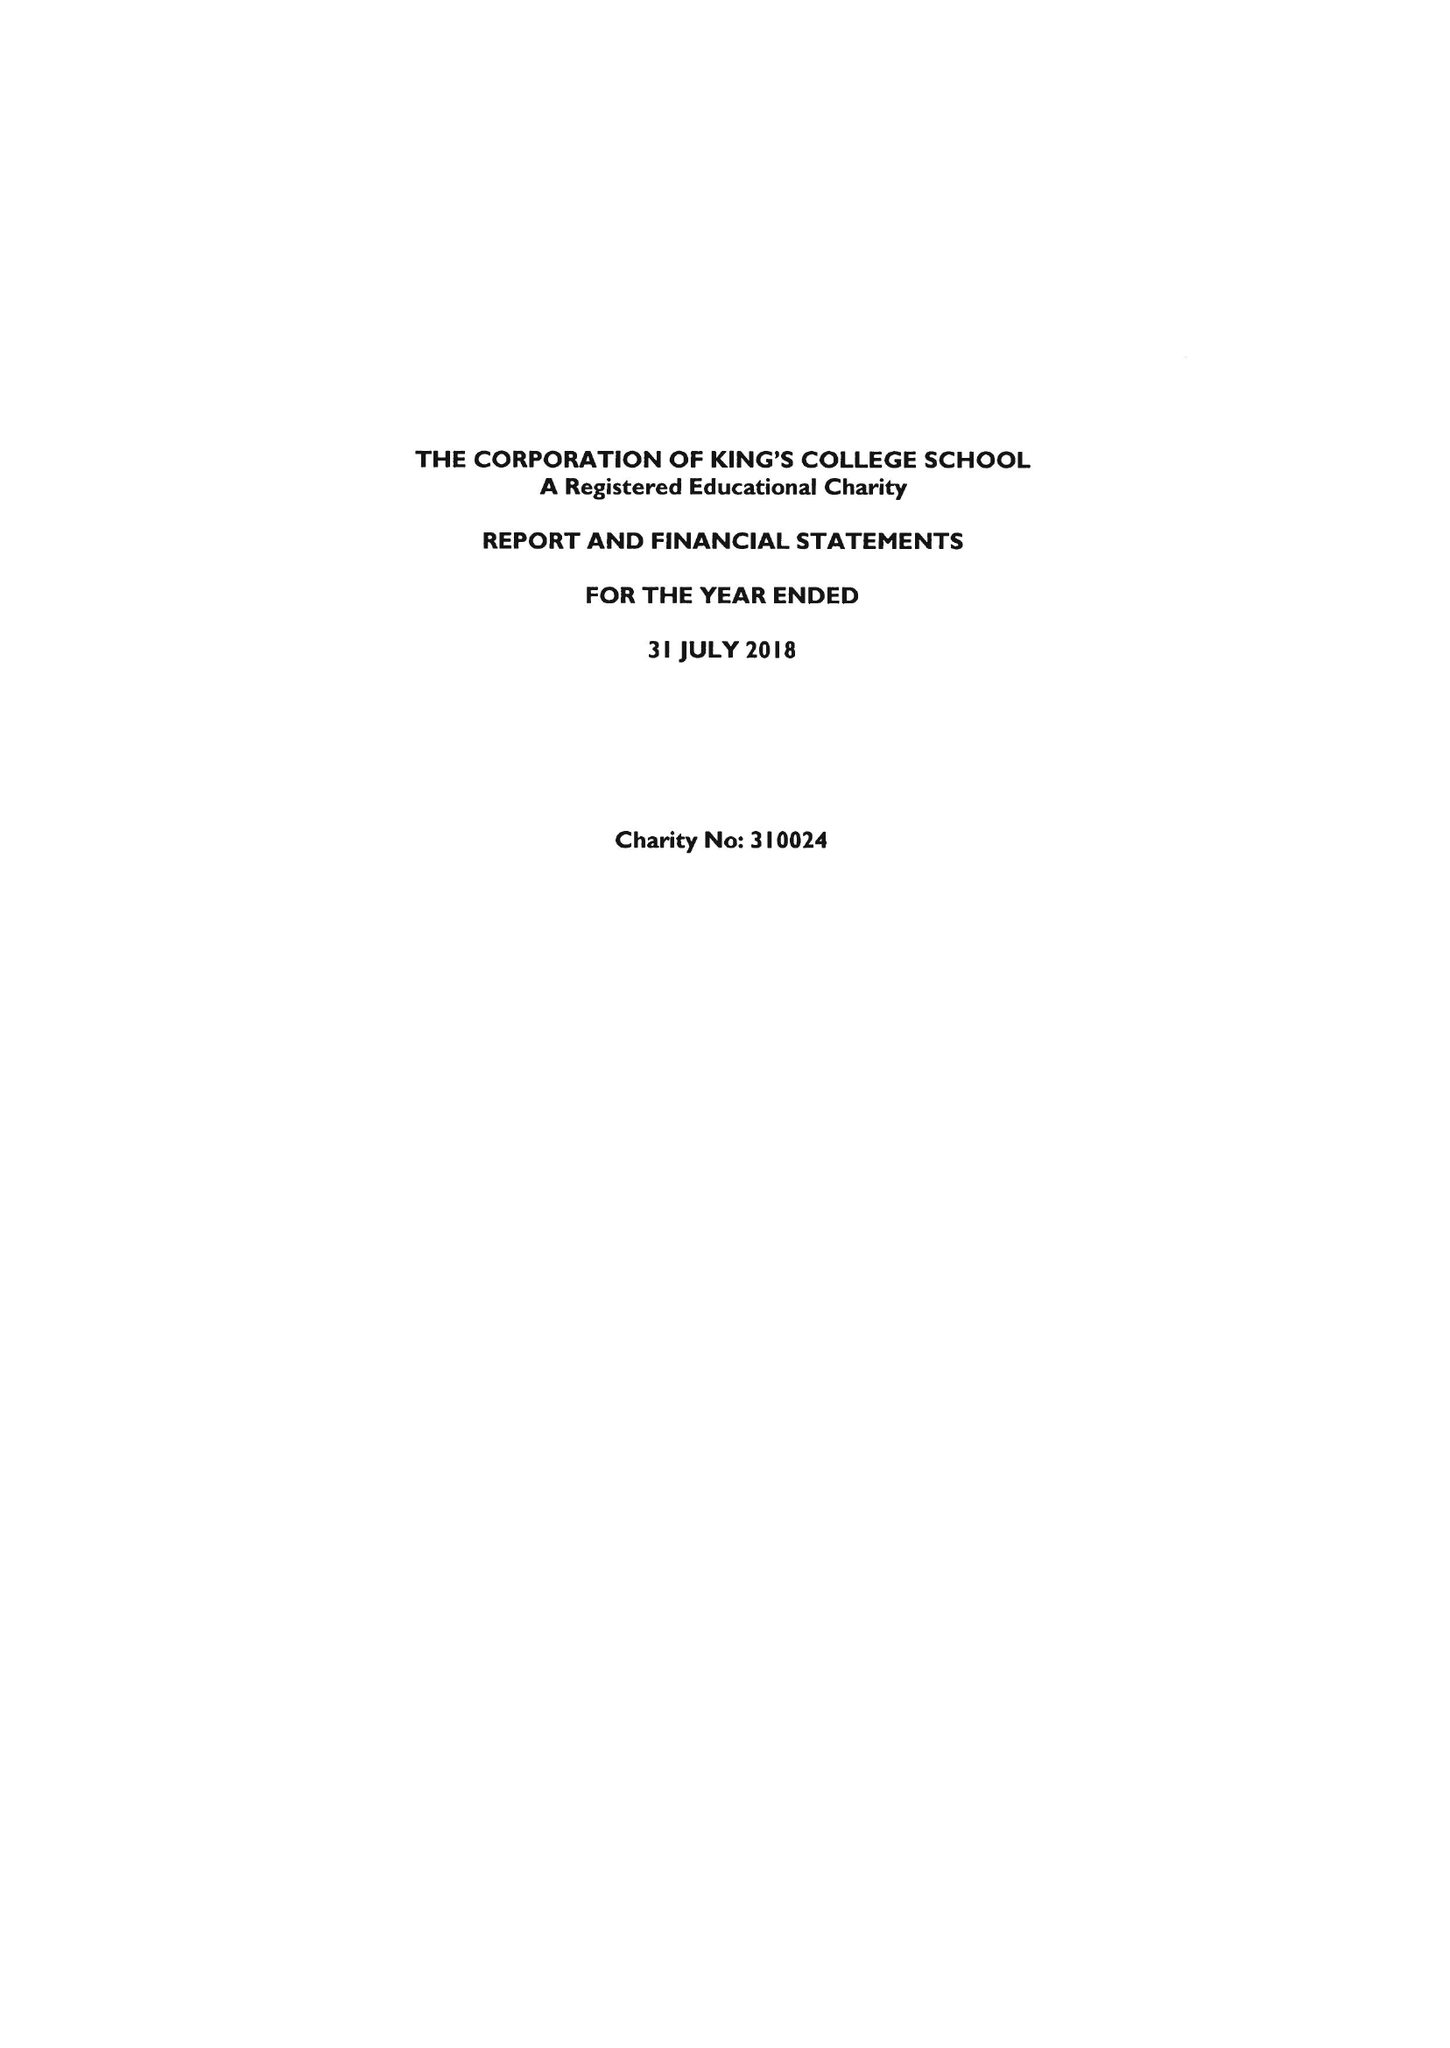What is the value for the address__post_town?
Answer the question using a single word or phrase. LONDON 